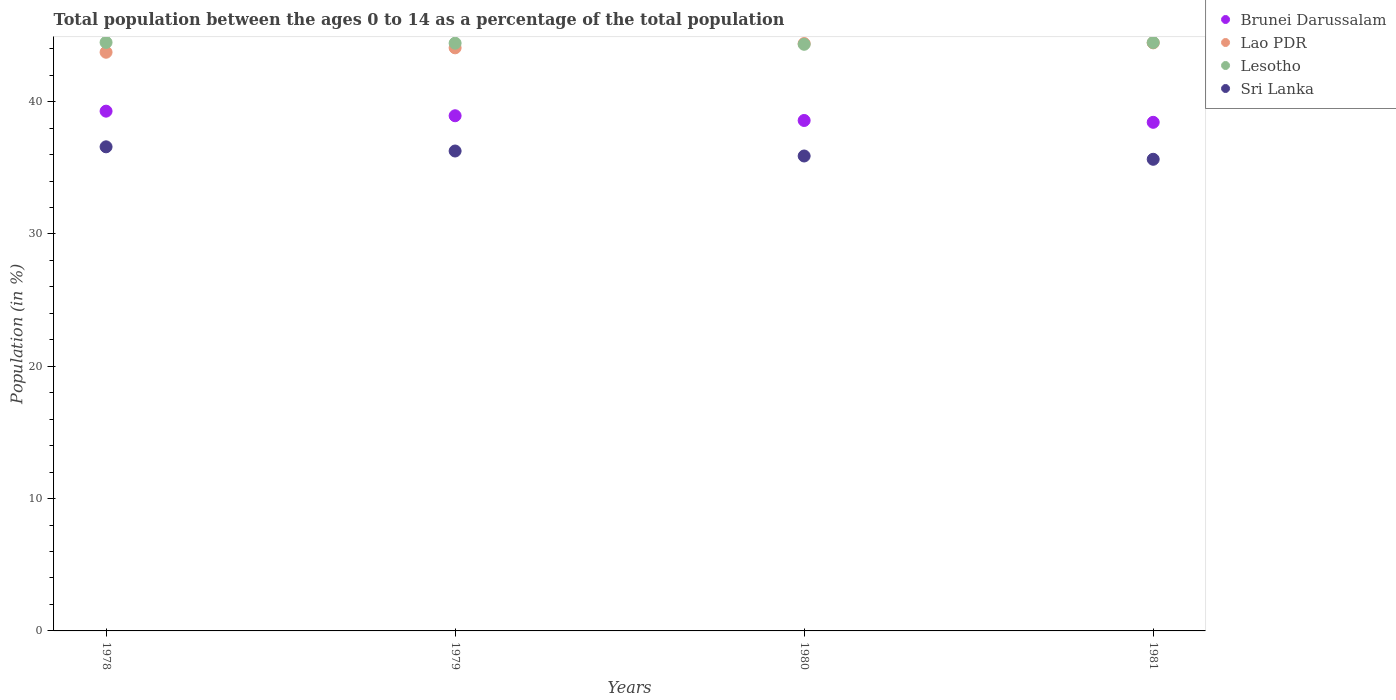How many different coloured dotlines are there?
Give a very brief answer. 4. What is the percentage of the population ages 0 to 14 in Lao PDR in 1978?
Offer a terse response. 43.73. Across all years, what is the maximum percentage of the population ages 0 to 14 in Lao PDR?
Ensure brevity in your answer.  44.44. Across all years, what is the minimum percentage of the population ages 0 to 14 in Brunei Darussalam?
Your answer should be very brief. 38.44. In which year was the percentage of the population ages 0 to 14 in Sri Lanka maximum?
Make the answer very short. 1978. In which year was the percentage of the population ages 0 to 14 in Lao PDR minimum?
Your answer should be compact. 1978. What is the total percentage of the population ages 0 to 14 in Sri Lanka in the graph?
Your answer should be compact. 144.39. What is the difference between the percentage of the population ages 0 to 14 in Brunei Darussalam in 1979 and that in 1980?
Offer a very short reply. 0.36. What is the difference between the percentage of the population ages 0 to 14 in Brunei Darussalam in 1979 and the percentage of the population ages 0 to 14 in Lao PDR in 1980?
Offer a very short reply. -5.46. What is the average percentage of the population ages 0 to 14 in Lao PDR per year?
Provide a succinct answer. 44.16. In the year 1981, what is the difference between the percentage of the population ages 0 to 14 in Sri Lanka and percentage of the population ages 0 to 14 in Lesotho?
Provide a succinct answer. -8.82. What is the ratio of the percentage of the population ages 0 to 14 in Brunei Darussalam in 1979 to that in 1980?
Ensure brevity in your answer.  1.01. Is the difference between the percentage of the population ages 0 to 14 in Sri Lanka in 1978 and 1979 greater than the difference between the percentage of the population ages 0 to 14 in Lesotho in 1978 and 1979?
Your answer should be compact. Yes. What is the difference between the highest and the second highest percentage of the population ages 0 to 14 in Lesotho?
Offer a terse response. 0.01. What is the difference between the highest and the lowest percentage of the population ages 0 to 14 in Sri Lanka?
Give a very brief answer. 0.94. In how many years, is the percentage of the population ages 0 to 14 in Lesotho greater than the average percentage of the population ages 0 to 14 in Lesotho taken over all years?
Give a very brief answer. 2. Does the percentage of the population ages 0 to 14 in Lesotho monotonically increase over the years?
Give a very brief answer. No. How many dotlines are there?
Provide a short and direct response. 4. How many years are there in the graph?
Keep it short and to the point. 4. Does the graph contain any zero values?
Your answer should be very brief. No. Does the graph contain grids?
Your response must be concise. No. How many legend labels are there?
Offer a terse response. 4. How are the legend labels stacked?
Your response must be concise. Vertical. What is the title of the graph?
Keep it short and to the point. Total population between the ages 0 to 14 as a percentage of the total population. Does "Bolivia" appear as one of the legend labels in the graph?
Provide a succinct answer. No. What is the label or title of the X-axis?
Your answer should be compact. Years. What is the Population (in %) of Brunei Darussalam in 1978?
Provide a succinct answer. 39.28. What is the Population (in %) in Lao PDR in 1978?
Make the answer very short. 43.73. What is the Population (in %) of Lesotho in 1978?
Your answer should be very brief. 44.48. What is the Population (in %) of Sri Lanka in 1978?
Give a very brief answer. 36.59. What is the Population (in %) in Brunei Darussalam in 1979?
Give a very brief answer. 38.93. What is the Population (in %) in Lao PDR in 1979?
Provide a short and direct response. 44.07. What is the Population (in %) of Lesotho in 1979?
Make the answer very short. 44.42. What is the Population (in %) of Sri Lanka in 1979?
Your response must be concise. 36.27. What is the Population (in %) of Brunei Darussalam in 1980?
Give a very brief answer. 38.58. What is the Population (in %) of Lao PDR in 1980?
Make the answer very short. 44.39. What is the Population (in %) of Lesotho in 1980?
Make the answer very short. 44.33. What is the Population (in %) in Sri Lanka in 1980?
Make the answer very short. 35.89. What is the Population (in %) in Brunei Darussalam in 1981?
Offer a very short reply. 38.44. What is the Population (in %) in Lao PDR in 1981?
Keep it short and to the point. 44.44. What is the Population (in %) of Lesotho in 1981?
Your answer should be very brief. 44.47. What is the Population (in %) in Sri Lanka in 1981?
Provide a succinct answer. 35.64. Across all years, what is the maximum Population (in %) in Brunei Darussalam?
Provide a short and direct response. 39.28. Across all years, what is the maximum Population (in %) of Lao PDR?
Your answer should be compact. 44.44. Across all years, what is the maximum Population (in %) in Lesotho?
Keep it short and to the point. 44.48. Across all years, what is the maximum Population (in %) of Sri Lanka?
Offer a terse response. 36.59. Across all years, what is the minimum Population (in %) in Brunei Darussalam?
Offer a terse response. 38.44. Across all years, what is the minimum Population (in %) in Lao PDR?
Offer a terse response. 43.73. Across all years, what is the minimum Population (in %) of Lesotho?
Provide a short and direct response. 44.33. Across all years, what is the minimum Population (in %) of Sri Lanka?
Provide a succinct answer. 35.64. What is the total Population (in %) of Brunei Darussalam in the graph?
Offer a terse response. 155.23. What is the total Population (in %) of Lao PDR in the graph?
Provide a succinct answer. 176.64. What is the total Population (in %) in Lesotho in the graph?
Ensure brevity in your answer.  177.7. What is the total Population (in %) in Sri Lanka in the graph?
Offer a very short reply. 144.39. What is the difference between the Population (in %) of Brunei Darussalam in 1978 and that in 1979?
Provide a succinct answer. 0.35. What is the difference between the Population (in %) of Lao PDR in 1978 and that in 1979?
Provide a succinct answer. -0.33. What is the difference between the Population (in %) of Lesotho in 1978 and that in 1979?
Your answer should be compact. 0.06. What is the difference between the Population (in %) in Sri Lanka in 1978 and that in 1979?
Ensure brevity in your answer.  0.32. What is the difference between the Population (in %) of Brunei Darussalam in 1978 and that in 1980?
Offer a terse response. 0.7. What is the difference between the Population (in %) in Lao PDR in 1978 and that in 1980?
Keep it short and to the point. -0.66. What is the difference between the Population (in %) of Lesotho in 1978 and that in 1980?
Your answer should be compact. 0.14. What is the difference between the Population (in %) in Sri Lanka in 1978 and that in 1980?
Make the answer very short. 0.69. What is the difference between the Population (in %) of Brunei Darussalam in 1978 and that in 1981?
Your response must be concise. 0.84. What is the difference between the Population (in %) of Lao PDR in 1978 and that in 1981?
Your answer should be compact. -0.71. What is the difference between the Population (in %) of Lesotho in 1978 and that in 1981?
Offer a terse response. 0.01. What is the difference between the Population (in %) in Sri Lanka in 1978 and that in 1981?
Give a very brief answer. 0.94. What is the difference between the Population (in %) in Brunei Darussalam in 1979 and that in 1980?
Provide a succinct answer. 0.36. What is the difference between the Population (in %) of Lao PDR in 1979 and that in 1980?
Keep it short and to the point. -0.32. What is the difference between the Population (in %) in Lesotho in 1979 and that in 1980?
Make the answer very short. 0.08. What is the difference between the Population (in %) in Sri Lanka in 1979 and that in 1980?
Your answer should be very brief. 0.38. What is the difference between the Population (in %) of Brunei Darussalam in 1979 and that in 1981?
Give a very brief answer. 0.5. What is the difference between the Population (in %) in Lao PDR in 1979 and that in 1981?
Your answer should be compact. -0.38. What is the difference between the Population (in %) of Lesotho in 1979 and that in 1981?
Offer a terse response. -0.05. What is the difference between the Population (in %) of Sri Lanka in 1979 and that in 1981?
Your answer should be compact. 0.63. What is the difference between the Population (in %) in Brunei Darussalam in 1980 and that in 1981?
Make the answer very short. 0.14. What is the difference between the Population (in %) in Lao PDR in 1980 and that in 1981?
Provide a succinct answer. -0.05. What is the difference between the Population (in %) in Lesotho in 1980 and that in 1981?
Provide a short and direct response. -0.13. What is the difference between the Population (in %) in Sri Lanka in 1980 and that in 1981?
Offer a terse response. 0.25. What is the difference between the Population (in %) of Brunei Darussalam in 1978 and the Population (in %) of Lao PDR in 1979?
Make the answer very short. -4.79. What is the difference between the Population (in %) in Brunei Darussalam in 1978 and the Population (in %) in Lesotho in 1979?
Provide a short and direct response. -5.14. What is the difference between the Population (in %) in Brunei Darussalam in 1978 and the Population (in %) in Sri Lanka in 1979?
Your answer should be very brief. 3.01. What is the difference between the Population (in %) in Lao PDR in 1978 and the Population (in %) in Lesotho in 1979?
Ensure brevity in your answer.  -0.68. What is the difference between the Population (in %) of Lao PDR in 1978 and the Population (in %) of Sri Lanka in 1979?
Your answer should be compact. 7.46. What is the difference between the Population (in %) of Lesotho in 1978 and the Population (in %) of Sri Lanka in 1979?
Offer a terse response. 8.21. What is the difference between the Population (in %) in Brunei Darussalam in 1978 and the Population (in %) in Lao PDR in 1980?
Provide a succinct answer. -5.11. What is the difference between the Population (in %) in Brunei Darussalam in 1978 and the Population (in %) in Lesotho in 1980?
Ensure brevity in your answer.  -5.05. What is the difference between the Population (in %) of Brunei Darussalam in 1978 and the Population (in %) of Sri Lanka in 1980?
Your answer should be compact. 3.39. What is the difference between the Population (in %) in Lao PDR in 1978 and the Population (in %) in Lesotho in 1980?
Make the answer very short. -0.6. What is the difference between the Population (in %) in Lao PDR in 1978 and the Population (in %) in Sri Lanka in 1980?
Your response must be concise. 7.84. What is the difference between the Population (in %) in Lesotho in 1978 and the Population (in %) in Sri Lanka in 1980?
Give a very brief answer. 8.58. What is the difference between the Population (in %) of Brunei Darussalam in 1978 and the Population (in %) of Lao PDR in 1981?
Your response must be concise. -5.16. What is the difference between the Population (in %) of Brunei Darussalam in 1978 and the Population (in %) of Lesotho in 1981?
Offer a very short reply. -5.19. What is the difference between the Population (in %) of Brunei Darussalam in 1978 and the Population (in %) of Sri Lanka in 1981?
Offer a very short reply. 3.64. What is the difference between the Population (in %) in Lao PDR in 1978 and the Population (in %) in Lesotho in 1981?
Give a very brief answer. -0.73. What is the difference between the Population (in %) of Lao PDR in 1978 and the Population (in %) of Sri Lanka in 1981?
Give a very brief answer. 8.09. What is the difference between the Population (in %) in Lesotho in 1978 and the Population (in %) in Sri Lanka in 1981?
Your response must be concise. 8.83. What is the difference between the Population (in %) of Brunei Darussalam in 1979 and the Population (in %) of Lao PDR in 1980?
Your response must be concise. -5.46. What is the difference between the Population (in %) in Brunei Darussalam in 1979 and the Population (in %) in Lesotho in 1980?
Keep it short and to the point. -5.4. What is the difference between the Population (in %) in Brunei Darussalam in 1979 and the Population (in %) in Sri Lanka in 1980?
Give a very brief answer. 3.04. What is the difference between the Population (in %) of Lao PDR in 1979 and the Population (in %) of Lesotho in 1980?
Offer a very short reply. -0.27. What is the difference between the Population (in %) in Lao PDR in 1979 and the Population (in %) in Sri Lanka in 1980?
Make the answer very short. 8.17. What is the difference between the Population (in %) in Lesotho in 1979 and the Population (in %) in Sri Lanka in 1980?
Make the answer very short. 8.53. What is the difference between the Population (in %) of Brunei Darussalam in 1979 and the Population (in %) of Lao PDR in 1981?
Make the answer very short. -5.51. What is the difference between the Population (in %) in Brunei Darussalam in 1979 and the Population (in %) in Lesotho in 1981?
Offer a terse response. -5.53. What is the difference between the Population (in %) in Brunei Darussalam in 1979 and the Population (in %) in Sri Lanka in 1981?
Provide a short and direct response. 3.29. What is the difference between the Population (in %) in Lao PDR in 1979 and the Population (in %) in Lesotho in 1981?
Provide a succinct answer. -0.4. What is the difference between the Population (in %) in Lao PDR in 1979 and the Population (in %) in Sri Lanka in 1981?
Ensure brevity in your answer.  8.42. What is the difference between the Population (in %) of Lesotho in 1979 and the Population (in %) of Sri Lanka in 1981?
Your answer should be compact. 8.78. What is the difference between the Population (in %) of Brunei Darussalam in 1980 and the Population (in %) of Lao PDR in 1981?
Give a very brief answer. -5.87. What is the difference between the Population (in %) of Brunei Darussalam in 1980 and the Population (in %) of Lesotho in 1981?
Give a very brief answer. -5.89. What is the difference between the Population (in %) in Brunei Darussalam in 1980 and the Population (in %) in Sri Lanka in 1981?
Your answer should be very brief. 2.93. What is the difference between the Population (in %) in Lao PDR in 1980 and the Population (in %) in Lesotho in 1981?
Provide a short and direct response. -0.08. What is the difference between the Population (in %) of Lao PDR in 1980 and the Population (in %) of Sri Lanka in 1981?
Keep it short and to the point. 8.75. What is the difference between the Population (in %) in Lesotho in 1980 and the Population (in %) in Sri Lanka in 1981?
Your answer should be very brief. 8.69. What is the average Population (in %) of Brunei Darussalam per year?
Your response must be concise. 38.81. What is the average Population (in %) of Lao PDR per year?
Your answer should be very brief. 44.16. What is the average Population (in %) in Lesotho per year?
Your response must be concise. 44.42. What is the average Population (in %) in Sri Lanka per year?
Keep it short and to the point. 36.1. In the year 1978, what is the difference between the Population (in %) in Brunei Darussalam and Population (in %) in Lao PDR?
Provide a succinct answer. -4.45. In the year 1978, what is the difference between the Population (in %) in Brunei Darussalam and Population (in %) in Lesotho?
Ensure brevity in your answer.  -5.2. In the year 1978, what is the difference between the Population (in %) in Brunei Darussalam and Population (in %) in Sri Lanka?
Make the answer very short. 2.7. In the year 1978, what is the difference between the Population (in %) in Lao PDR and Population (in %) in Lesotho?
Provide a short and direct response. -0.74. In the year 1978, what is the difference between the Population (in %) of Lao PDR and Population (in %) of Sri Lanka?
Provide a short and direct response. 7.15. In the year 1978, what is the difference between the Population (in %) of Lesotho and Population (in %) of Sri Lanka?
Ensure brevity in your answer.  7.89. In the year 1979, what is the difference between the Population (in %) in Brunei Darussalam and Population (in %) in Lao PDR?
Provide a succinct answer. -5.13. In the year 1979, what is the difference between the Population (in %) of Brunei Darussalam and Population (in %) of Lesotho?
Give a very brief answer. -5.48. In the year 1979, what is the difference between the Population (in %) in Brunei Darussalam and Population (in %) in Sri Lanka?
Provide a short and direct response. 2.66. In the year 1979, what is the difference between the Population (in %) in Lao PDR and Population (in %) in Lesotho?
Your answer should be compact. -0.35. In the year 1979, what is the difference between the Population (in %) of Lao PDR and Population (in %) of Sri Lanka?
Your answer should be compact. 7.8. In the year 1979, what is the difference between the Population (in %) in Lesotho and Population (in %) in Sri Lanka?
Your response must be concise. 8.15. In the year 1980, what is the difference between the Population (in %) of Brunei Darussalam and Population (in %) of Lao PDR?
Your answer should be compact. -5.81. In the year 1980, what is the difference between the Population (in %) of Brunei Darussalam and Population (in %) of Lesotho?
Make the answer very short. -5.76. In the year 1980, what is the difference between the Population (in %) of Brunei Darussalam and Population (in %) of Sri Lanka?
Keep it short and to the point. 2.68. In the year 1980, what is the difference between the Population (in %) of Lao PDR and Population (in %) of Lesotho?
Provide a short and direct response. 0.06. In the year 1980, what is the difference between the Population (in %) of Lao PDR and Population (in %) of Sri Lanka?
Your response must be concise. 8.5. In the year 1980, what is the difference between the Population (in %) of Lesotho and Population (in %) of Sri Lanka?
Ensure brevity in your answer.  8.44. In the year 1981, what is the difference between the Population (in %) of Brunei Darussalam and Population (in %) of Lao PDR?
Provide a succinct answer. -6. In the year 1981, what is the difference between the Population (in %) of Brunei Darussalam and Population (in %) of Lesotho?
Your answer should be compact. -6.03. In the year 1981, what is the difference between the Population (in %) of Brunei Darussalam and Population (in %) of Sri Lanka?
Keep it short and to the point. 2.79. In the year 1981, what is the difference between the Population (in %) in Lao PDR and Population (in %) in Lesotho?
Your response must be concise. -0.03. In the year 1981, what is the difference between the Population (in %) of Lao PDR and Population (in %) of Sri Lanka?
Provide a succinct answer. 8.8. In the year 1981, what is the difference between the Population (in %) of Lesotho and Population (in %) of Sri Lanka?
Provide a short and direct response. 8.82. What is the ratio of the Population (in %) of Brunei Darussalam in 1978 to that in 1979?
Offer a very short reply. 1.01. What is the ratio of the Population (in %) of Lao PDR in 1978 to that in 1979?
Provide a succinct answer. 0.99. What is the ratio of the Population (in %) of Lesotho in 1978 to that in 1979?
Ensure brevity in your answer.  1. What is the ratio of the Population (in %) in Sri Lanka in 1978 to that in 1979?
Your response must be concise. 1.01. What is the ratio of the Population (in %) of Brunei Darussalam in 1978 to that in 1980?
Provide a short and direct response. 1.02. What is the ratio of the Population (in %) in Lao PDR in 1978 to that in 1980?
Give a very brief answer. 0.99. What is the ratio of the Population (in %) in Sri Lanka in 1978 to that in 1980?
Make the answer very short. 1.02. What is the ratio of the Population (in %) of Brunei Darussalam in 1978 to that in 1981?
Keep it short and to the point. 1.02. What is the ratio of the Population (in %) in Lesotho in 1978 to that in 1981?
Give a very brief answer. 1. What is the ratio of the Population (in %) in Sri Lanka in 1978 to that in 1981?
Provide a short and direct response. 1.03. What is the ratio of the Population (in %) in Brunei Darussalam in 1979 to that in 1980?
Your answer should be very brief. 1.01. What is the ratio of the Population (in %) in Sri Lanka in 1979 to that in 1980?
Your answer should be compact. 1.01. What is the ratio of the Population (in %) of Brunei Darussalam in 1979 to that in 1981?
Your answer should be very brief. 1.01. What is the ratio of the Population (in %) of Sri Lanka in 1979 to that in 1981?
Make the answer very short. 1.02. What is the ratio of the Population (in %) in Lao PDR in 1980 to that in 1981?
Give a very brief answer. 1. What is the ratio of the Population (in %) of Sri Lanka in 1980 to that in 1981?
Offer a terse response. 1.01. What is the difference between the highest and the second highest Population (in %) in Brunei Darussalam?
Your response must be concise. 0.35. What is the difference between the highest and the second highest Population (in %) in Lao PDR?
Provide a succinct answer. 0.05. What is the difference between the highest and the second highest Population (in %) in Lesotho?
Offer a very short reply. 0.01. What is the difference between the highest and the second highest Population (in %) of Sri Lanka?
Offer a very short reply. 0.32. What is the difference between the highest and the lowest Population (in %) in Brunei Darussalam?
Your answer should be compact. 0.84. What is the difference between the highest and the lowest Population (in %) in Lao PDR?
Give a very brief answer. 0.71. What is the difference between the highest and the lowest Population (in %) in Lesotho?
Keep it short and to the point. 0.14. What is the difference between the highest and the lowest Population (in %) of Sri Lanka?
Provide a short and direct response. 0.94. 